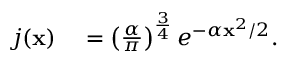<formula> <loc_0><loc_0><loc_500><loc_500>\begin{array} { r l } { j ( x ) } & = \left ( \frac { \alpha } { \pi } \right ) ^ { \frac { 3 } { 4 } } e ^ { - \alpha x ^ { 2 } / 2 } . } \end{array}</formula> 